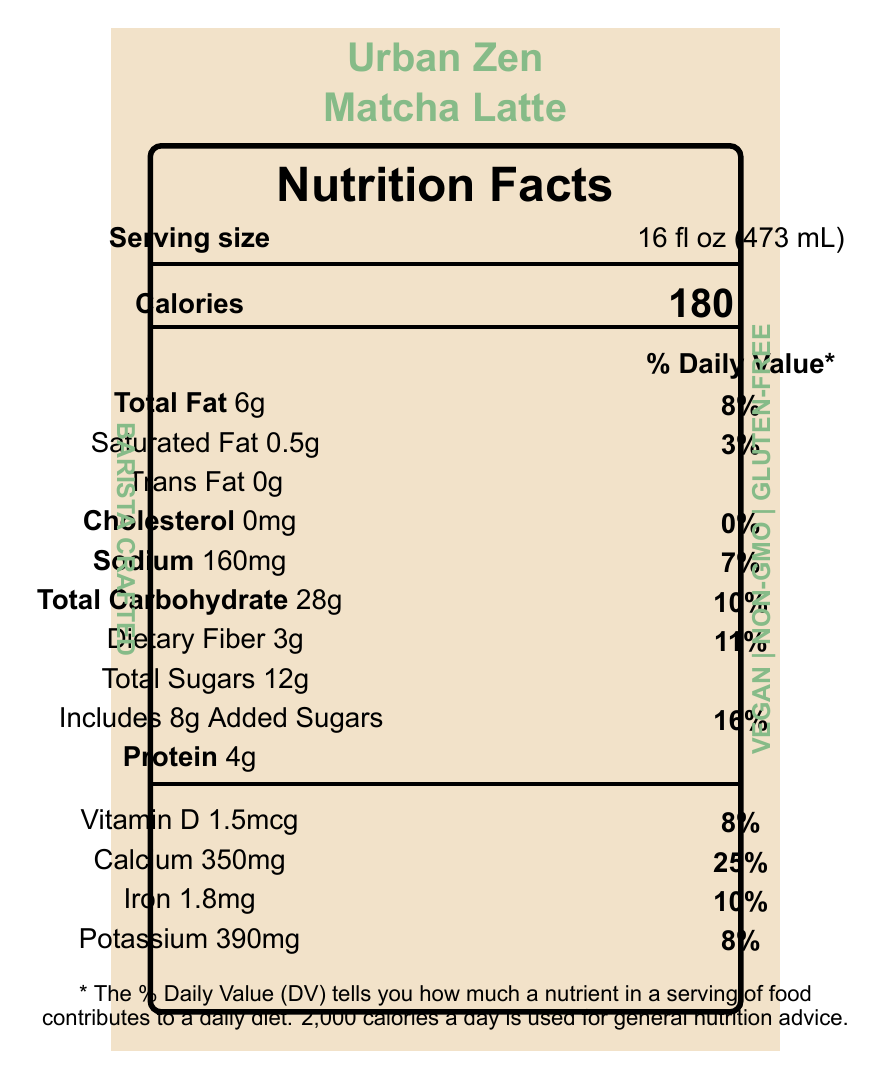what is the serving size of the Urban Zen Matcha Latte? The serving size is stated on the document as "16 fl oz (473 mL)".
Answer: 16 fl oz (473 mL) how many calories are there in one serving? The document shows that one serving has 180 calories.
Answer: 180 how much dietary fiber is in the Urban Zen Matcha Latte, and what percentage of the daily value does it represent? The document lists "Dietary Fiber 3g" and indicates that this represents 11% of the daily value.
Answer: 3g, 11% does the product contain any cholesterol? The document shows that the amount of cholesterol is 0mg.
Answer: No which mineral has the highest daily value percentage in this product? The daily value percentage for calcium is 25%, which is higher than any other mineral listed.
Answer: Calcium how many grams of total sugars are in one serving? The document lists the total amount of sugars as 12g.
Answer: 12g does the Urban Zen Matcha Latte include added sugars? If so, how many grams? The document specifies that 8g of the total sugars are added sugars.
Answer: Yes, 8g how much iron does this product contain? The document states that the product contains 1.8 mg of iron.
Answer: 1.8 mg what allergens are present in the Urban Zen Matcha Latte? The allergen section in the document indicates that the product contains oats.
Answer: Oats how is the product described with respect to dietary preferences and lifestyle? The additional information section includes these attributes, suggesting that the product caters to these dietary preferences and lifestyles.
Answer: Vegan, Non-GMO, Gluten-free, Barista crafted which ingredient is listed first in the ingredients list for Urban Zen Matcha Latte? The first ingredient listed in the document is "Oat milk (filtered water, oats)".
Answer: Oat milk (filtered water, oats) what is the percentage daily value of vitamin D in this product? The document lists the vitamin D daily value as 8%.
Answer: 8% which statement best describes the total daily value percentage for sodium in the Urban Zen Matcha Latte? A. 7% B. 10% C. 11% D. 16% The document lists the daily value percentage for sodium as 7%.
Answer: A. 7% what percentage of daily value does saturated fat represent in one serving of the Urban Zen Matcha Latte? A. 3% B. 5% C. 8% D. 10% The document shows that the daily value percentage for saturated fat is 3%.
Answer: A. 3% is the Urban Zen Matcha Latte a gluten-free product? The document includes "Gluten-free" in the additional information section, confirming it.
Answer: Yes summarize the main idea of the Urban Zen Matcha Latte nutrition label document. The document focuses on providing all necessary nutritional details and dietary benefits for the Urban Zen Matcha Latte to help consumers make informed choices.
Answer: The Urban Zen Matcha Latte nutrition label details the nutritional information of a 16 fl oz serving, including 180 calories, various percentages of daily values for fats, carbohydrates, and proteins, as well as vitamins and minerals it contains. It highlights that the product is vegan, non-GMO, and gluten-free. Other information includes natural ingredients used and potential allergens. what is the source of sweetness in the Urban Zen Matcha Latte? The ingredients list includes monk fruit sweetener and agave nectar, which are natural sweeteners.
Answer: Monk fruit sweetener, Agave nectar calculate the total fat percentage of two servings of Urban Zen Matcha Latte. For one serving, the total fat daily value is 8%. Therefore, for two servings, it would be 8% * 2 = 16%.
Answer: 16% what is the sugar content per 100 milliliters serving? The document does not provide sufficient information to directly calculate the sugar content per 100 milliliters.
Answer: Cannot be determined 